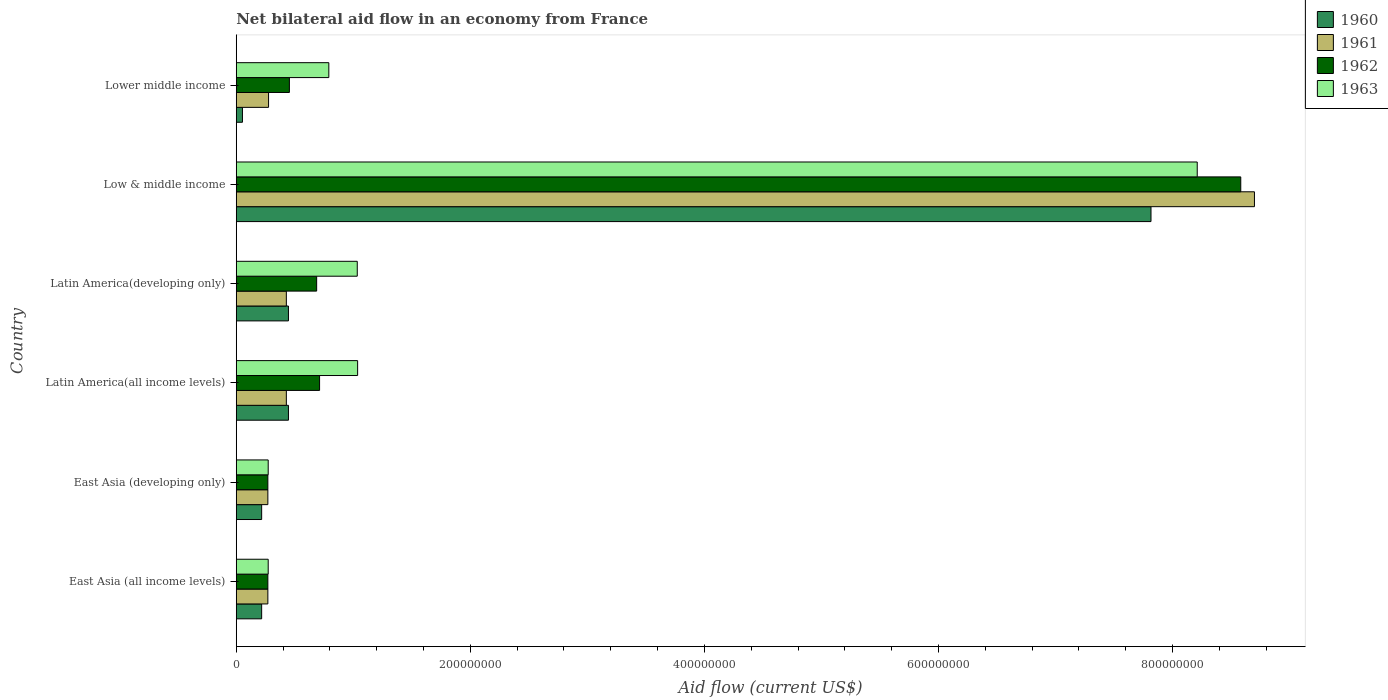Are the number of bars on each tick of the Y-axis equal?
Make the answer very short. Yes. How many bars are there on the 4th tick from the bottom?
Your answer should be compact. 4. What is the label of the 1st group of bars from the top?
Give a very brief answer. Lower middle income. What is the net bilateral aid flow in 1960 in East Asia (all income levels)?
Offer a very short reply. 2.17e+07. Across all countries, what is the maximum net bilateral aid flow in 1960?
Offer a very short reply. 7.82e+08. Across all countries, what is the minimum net bilateral aid flow in 1961?
Your answer should be compact. 2.70e+07. In which country was the net bilateral aid flow in 1962 maximum?
Offer a very short reply. Low & middle income. In which country was the net bilateral aid flow in 1963 minimum?
Your answer should be very brief. East Asia (all income levels). What is the total net bilateral aid flow in 1962 in the graph?
Provide a succinct answer. 1.10e+09. What is the difference between the net bilateral aid flow in 1961 in East Asia (developing only) and that in Latin America(developing only)?
Your answer should be very brief. -1.58e+07. What is the difference between the net bilateral aid flow in 1962 in Latin America(all income levels) and the net bilateral aid flow in 1960 in East Asia (developing only)?
Provide a short and direct response. 4.95e+07. What is the average net bilateral aid flow in 1962 per country?
Offer a terse response. 1.83e+08. What is the difference between the net bilateral aid flow in 1961 and net bilateral aid flow in 1963 in East Asia (developing only)?
Your answer should be very brief. -3.00e+05. What is the ratio of the net bilateral aid flow in 1960 in Latin America(all income levels) to that in Low & middle income?
Provide a short and direct response. 0.06. What is the difference between the highest and the second highest net bilateral aid flow in 1960?
Offer a terse response. 7.37e+08. What is the difference between the highest and the lowest net bilateral aid flow in 1960?
Your response must be concise. 7.76e+08. In how many countries, is the net bilateral aid flow in 1963 greater than the average net bilateral aid flow in 1963 taken over all countries?
Give a very brief answer. 1. Is the sum of the net bilateral aid flow in 1962 in Latin America(developing only) and Lower middle income greater than the maximum net bilateral aid flow in 1961 across all countries?
Your answer should be very brief. No. Is it the case that in every country, the sum of the net bilateral aid flow in 1961 and net bilateral aid flow in 1963 is greater than the sum of net bilateral aid flow in 1960 and net bilateral aid flow in 1962?
Make the answer very short. No. What does the 4th bar from the top in East Asia (all income levels) represents?
Provide a succinct answer. 1960. What does the 1st bar from the bottom in Latin America(developing only) represents?
Ensure brevity in your answer.  1960. How many bars are there?
Ensure brevity in your answer.  24. Are all the bars in the graph horizontal?
Your answer should be compact. Yes. What is the difference between two consecutive major ticks on the X-axis?
Keep it short and to the point. 2.00e+08. Does the graph contain any zero values?
Ensure brevity in your answer.  No. Where does the legend appear in the graph?
Provide a succinct answer. Top right. How many legend labels are there?
Your answer should be very brief. 4. What is the title of the graph?
Keep it short and to the point. Net bilateral aid flow in an economy from France. Does "2014" appear as one of the legend labels in the graph?
Offer a very short reply. No. What is the label or title of the X-axis?
Make the answer very short. Aid flow (current US$). What is the label or title of the Y-axis?
Your answer should be compact. Country. What is the Aid flow (current US$) of 1960 in East Asia (all income levels)?
Provide a short and direct response. 2.17e+07. What is the Aid flow (current US$) in 1961 in East Asia (all income levels)?
Provide a short and direct response. 2.70e+07. What is the Aid flow (current US$) in 1962 in East Asia (all income levels)?
Offer a very short reply. 2.70e+07. What is the Aid flow (current US$) in 1963 in East Asia (all income levels)?
Your answer should be very brief. 2.73e+07. What is the Aid flow (current US$) in 1960 in East Asia (developing only)?
Offer a very short reply. 2.17e+07. What is the Aid flow (current US$) of 1961 in East Asia (developing only)?
Give a very brief answer. 2.70e+07. What is the Aid flow (current US$) in 1962 in East Asia (developing only)?
Your answer should be compact. 2.70e+07. What is the Aid flow (current US$) in 1963 in East Asia (developing only)?
Give a very brief answer. 2.73e+07. What is the Aid flow (current US$) in 1960 in Latin America(all income levels)?
Give a very brief answer. 4.46e+07. What is the Aid flow (current US$) of 1961 in Latin America(all income levels)?
Offer a very short reply. 4.28e+07. What is the Aid flow (current US$) of 1962 in Latin America(all income levels)?
Provide a succinct answer. 7.12e+07. What is the Aid flow (current US$) of 1963 in Latin America(all income levels)?
Ensure brevity in your answer.  1.04e+08. What is the Aid flow (current US$) of 1960 in Latin America(developing only)?
Ensure brevity in your answer.  4.46e+07. What is the Aid flow (current US$) in 1961 in Latin America(developing only)?
Keep it short and to the point. 4.28e+07. What is the Aid flow (current US$) in 1962 in Latin America(developing only)?
Give a very brief answer. 6.87e+07. What is the Aid flow (current US$) of 1963 in Latin America(developing only)?
Make the answer very short. 1.03e+08. What is the Aid flow (current US$) of 1960 in Low & middle income?
Offer a very short reply. 7.82e+08. What is the Aid flow (current US$) in 1961 in Low & middle income?
Offer a terse response. 8.70e+08. What is the Aid flow (current US$) of 1962 in Low & middle income?
Offer a terse response. 8.58e+08. What is the Aid flow (current US$) of 1963 in Low & middle income?
Your answer should be compact. 8.21e+08. What is the Aid flow (current US$) of 1960 in Lower middle income?
Offer a terse response. 5.30e+06. What is the Aid flow (current US$) in 1961 in Lower middle income?
Give a very brief answer. 2.76e+07. What is the Aid flow (current US$) of 1962 in Lower middle income?
Provide a short and direct response. 4.54e+07. What is the Aid flow (current US$) of 1963 in Lower middle income?
Make the answer very short. 7.91e+07. Across all countries, what is the maximum Aid flow (current US$) in 1960?
Make the answer very short. 7.82e+08. Across all countries, what is the maximum Aid flow (current US$) of 1961?
Give a very brief answer. 8.70e+08. Across all countries, what is the maximum Aid flow (current US$) in 1962?
Your answer should be very brief. 8.58e+08. Across all countries, what is the maximum Aid flow (current US$) of 1963?
Offer a very short reply. 8.21e+08. Across all countries, what is the minimum Aid flow (current US$) of 1960?
Keep it short and to the point. 5.30e+06. Across all countries, what is the minimum Aid flow (current US$) of 1961?
Provide a short and direct response. 2.70e+07. Across all countries, what is the minimum Aid flow (current US$) of 1962?
Offer a very short reply. 2.70e+07. Across all countries, what is the minimum Aid flow (current US$) in 1963?
Your response must be concise. 2.73e+07. What is the total Aid flow (current US$) in 1960 in the graph?
Offer a very short reply. 9.20e+08. What is the total Aid flow (current US$) in 1961 in the graph?
Your answer should be very brief. 1.04e+09. What is the total Aid flow (current US$) of 1962 in the graph?
Give a very brief answer. 1.10e+09. What is the total Aid flow (current US$) of 1963 in the graph?
Your answer should be compact. 1.16e+09. What is the difference between the Aid flow (current US$) in 1961 in East Asia (all income levels) and that in East Asia (developing only)?
Offer a very short reply. 0. What is the difference between the Aid flow (current US$) in 1963 in East Asia (all income levels) and that in East Asia (developing only)?
Provide a short and direct response. 0. What is the difference between the Aid flow (current US$) in 1960 in East Asia (all income levels) and that in Latin America(all income levels)?
Keep it short and to the point. -2.29e+07. What is the difference between the Aid flow (current US$) in 1961 in East Asia (all income levels) and that in Latin America(all income levels)?
Offer a terse response. -1.58e+07. What is the difference between the Aid flow (current US$) of 1962 in East Asia (all income levels) and that in Latin America(all income levels)?
Make the answer very short. -4.42e+07. What is the difference between the Aid flow (current US$) in 1963 in East Asia (all income levels) and that in Latin America(all income levels)?
Provide a short and direct response. -7.64e+07. What is the difference between the Aid flow (current US$) of 1960 in East Asia (all income levels) and that in Latin America(developing only)?
Offer a terse response. -2.29e+07. What is the difference between the Aid flow (current US$) of 1961 in East Asia (all income levels) and that in Latin America(developing only)?
Provide a short and direct response. -1.58e+07. What is the difference between the Aid flow (current US$) of 1962 in East Asia (all income levels) and that in Latin America(developing only)?
Offer a very short reply. -4.17e+07. What is the difference between the Aid flow (current US$) of 1963 in East Asia (all income levels) and that in Latin America(developing only)?
Your answer should be compact. -7.61e+07. What is the difference between the Aid flow (current US$) in 1960 in East Asia (all income levels) and that in Low & middle income?
Offer a terse response. -7.60e+08. What is the difference between the Aid flow (current US$) of 1961 in East Asia (all income levels) and that in Low & middle income?
Provide a short and direct response. -8.43e+08. What is the difference between the Aid flow (current US$) in 1962 in East Asia (all income levels) and that in Low & middle income?
Provide a short and direct response. -8.31e+08. What is the difference between the Aid flow (current US$) in 1963 in East Asia (all income levels) and that in Low & middle income?
Your answer should be compact. -7.94e+08. What is the difference between the Aid flow (current US$) in 1960 in East Asia (all income levels) and that in Lower middle income?
Your answer should be compact. 1.64e+07. What is the difference between the Aid flow (current US$) in 1961 in East Asia (all income levels) and that in Lower middle income?
Your response must be concise. -6.00e+05. What is the difference between the Aid flow (current US$) of 1962 in East Asia (all income levels) and that in Lower middle income?
Ensure brevity in your answer.  -1.84e+07. What is the difference between the Aid flow (current US$) in 1963 in East Asia (all income levels) and that in Lower middle income?
Provide a short and direct response. -5.18e+07. What is the difference between the Aid flow (current US$) of 1960 in East Asia (developing only) and that in Latin America(all income levels)?
Offer a terse response. -2.29e+07. What is the difference between the Aid flow (current US$) of 1961 in East Asia (developing only) and that in Latin America(all income levels)?
Provide a short and direct response. -1.58e+07. What is the difference between the Aid flow (current US$) of 1962 in East Asia (developing only) and that in Latin America(all income levels)?
Provide a succinct answer. -4.42e+07. What is the difference between the Aid flow (current US$) of 1963 in East Asia (developing only) and that in Latin America(all income levels)?
Provide a short and direct response. -7.64e+07. What is the difference between the Aid flow (current US$) of 1960 in East Asia (developing only) and that in Latin America(developing only)?
Your answer should be compact. -2.29e+07. What is the difference between the Aid flow (current US$) of 1961 in East Asia (developing only) and that in Latin America(developing only)?
Offer a very short reply. -1.58e+07. What is the difference between the Aid flow (current US$) in 1962 in East Asia (developing only) and that in Latin America(developing only)?
Your response must be concise. -4.17e+07. What is the difference between the Aid flow (current US$) of 1963 in East Asia (developing only) and that in Latin America(developing only)?
Your response must be concise. -7.61e+07. What is the difference between the Aid flow (current US$) of 1960 in East Asia (developing only) and that in Low & middle income?
Ensure brevity in your answer.  -7.60e+08. What is the difference between the Aid flow (current US$) in 1961 in East Asia (developing only) and that in Low & middle income?
Offer a terse response. -8.43e+08. What is the difference between the Aid flow (current US$) in 1962 in East Asia (developing only) and that in Low & middle income?
Give a very brief answer. -8.31e+08. What is the difference between the Aid flow (current US$) in 1963 in East Asia (developing only) and that in Low & middle income?
Your answer should be compact. -7.94e+08. What is the difference between the Aid flow (current US$) of 1960 in East Asia (developing only) and that in Lower middle income?
Ensure brevity in your answer.  1.64e+07. What is the difference between the Aid flow (current US$) of 1961 in East Asia (developing only) and that in Lower middle income?
Your answer should be very brief. -6.00e+05. What is the difference between the Aid flow (current US$) in 1962 in East Asia (developing only) and that in Lower middle income?
Make the answer very short. -1.84e+07. What is the difference between the Aid flow (current US$) in 1963 in East Asia (developing only) and that in Lower middle income?
Your answer should be very brief. -5.18e+07. What is the difference between the Aid flow (current US$) of 1960 in Latin America(all income levels) and that in Latin America(developing only)?
Keep it short and to the point. 0. What is the difference between the Aid flow (current US$) of 1962 in Latin America(all income levels) and that in Latin America(developing only)?
Keep it short and to the point. 2.50e+06. What is the difference between the Aid flow (current US$) of 1963 in Latin America(all income levels) and that in Latin America(developing only)?
Offer a terse response. 3.00e+05. What is the difference between the Aid flow (current US$) of 1960 in Latin America(all income levels) and that in Low & middle income?
Give a very brief answer. -7.37e+08. What is the difference between the Aid flow (current US$) of 1961 in Latin America(all income levels) and that in Low & middle income?
Ensure brevity in your answer.  -8.27e+08. What is the difference between the Aid flow (current US$) in 1962 in Latin America(all income levels) and that in Low & middle income?
Your response must be concise. -7.87e+08. What is the difference between the Aid flow (current US$) in 1963 in Latin America(all income levels) and that in Low & middle income?
Your answer should be very brief. -7.17e+08. What is the difference between the Aid flow (current US$) in 1960 in Latin America(all income levels) and that in Lower middle income?
Provide a succinct answer. 3.93e+07. What is the difference between the Aid flow (current US$) of 1961 in Latin America(all income levels) and that in Lower middle income?
Provide a succinct answer. 1.52e+07. What is the difference between the Aid flow (current US$) of 1962 in Latin America(all income levels) and that in Lower middle income?
Your answer should be compact. 2.58e+07. What is the difference between the Aid flow (current US$) of 1963 in Latin America(all income levels) and that in Lower middle income?
Offer a very short reply. 2.46e+07. What is the difference between the Aid flow (current US$) of 1960 in Latin America(developing only) and that in Low & middle income?
Provide a short and direct response. -7.37e+08. What is the difference between the Aid flow (current US$) in 1961 in Latin America(developing only) and that in Low & middle income?
Make the answer very short. -8.27e+08. What is the difference between the Aid flow (current US$) in 1962 in Latin America(developing only) and that in Low & middle income?
Make the answer very short. -7.90e+08. What is the difference between the Aid flow (current US$) in 1963 in Latin America(developing only) and that in Low & middle income?
Provide a succinct answer. -7.18e+08. What is the difference between the Aid flow (current US$) in 1960 in Latin America(developing only) and that in Lower middle income?
Provide a short and direct response. 3.93e+07. What is the difference between the Aid flow (current US$) in 1961 in Latin America(developing only) and that in Lower middle income?
Your response must be concise. 1.52e+07. What is the difference between the Aid flow (current US$) in 1962 in Latin America(developing only) and that in Lower middle income?
Keep it short and to the point. 2.33e+07. What is the difference between the Aid flow (current US$) of 1963 in Latin America(developing only) and that in Lower middle income?
Ensure brevity in your answer.  2.43e+07. What is the difference between the Aid flow (current US$) in 1960 in Low & middle income and that in Lower middle income?
Offer a terse response. 7.76e+08. What is the difference between the Aid flow (current US$) of 1961 in Low & middle income and that in Lower middle income?
Make the answer very short. 8.42e+08. What is the difference between the Aid flow (current US$) in 1962 in Low & middle income and that in Lower middle income?
Your answer should be compact. 8.13e+08. What is the difference between the Aid flow (current US$) in 1963 in Low & middle income and that in Lower middle income?
Your response must be concise. 7.42e+08. What is the difference between the Aid flow (current US$) of 1960 in East Asia (all income levels) and the Aid flow (current US$) of 1961 in East Asia (developing only)?
Provide a short and direct response. -5.30e+06. What is the difference between the Aid flow (current US$) in 1960 in East Asia (all income levels) and the Aid flow (current US$) in 1962 in East Asia (developing only)?
Ensure brevity in your answer.  -5.30e+06. What is the difference between the Aid flow (current US$) of 1960 in East Asia (all income levels) and the Aid flow (current US$) of 1963 in East Asia (developing only)?
Your answer should be compact. -5.60e+06. What is the difference between the Aid flow (current US$) of 1961 in East Asia (all income levels) and the Aid flow (current US$) of 1962 in East Asia (developing only)?
Ensure brevity in your answer.  0. What is the difference between the Aid flow (current US$) of 1961 in East Asia (all income levels) and the Aid flow (current US$) of 1963 in East Asia (developing only)?
Offer a terse response. -3.00e+05. What is the difference between the Aid flow (current US$) in 1960 in East Asia (all income levels) and the Aid flow (current US$) in 1961 in Latin America(all income levels)?
Provide a short and direct response. -2.11e+07. What is the difference between the Aid flow (current US$) in 1960 in East Asia (all income levels) and the Aid flow (current US$) in 1962 in Latin America(all income levels)?
Provide a short and direct response. -4.95e+07. What is the difference between the Aid flow (current US$) in 1960 in East Asia (all income levels) and the Aid flow (current US$) in 1963 in Latin America(all income levels)?
Keep it short and to the point. -8.20e+07. What is the difference between the Aid flow (current US$) in 1961 in East Asia (all income levels) and the Aid flow (current US$) in 1962 in Latin America(all income levels)?
Your answer should be very brief. -4.42e+07. What is the difference between the Aid flow (current US$) of 1961 in East Asia (all income levels) and the Aid flow (current US$) of 1963 in Latin America(all income levels)?
Your answer should be compact. -7.67e+07. What is the difference between the Aid flow (current US$) of 1962 in East Asia (all income levels) and the Aid flow (current US$) of 1963 in Latin America(all income levels)?
Provide a succinct answer. -7.67e+07. What is the difference between the Aid flow (current US$) of 1960 in East Asia (all income levels) and the Aid flow (current US$) of 1961 in Latin America(developing only)?
Your response must be concise. -2.11e+07. What is the difference between the Aid flow (current US$) in 1960 in East Asia (all income levels) and the Aid flow (current US$) in 1962 in Latin America(developing only)?
Provide a succinct answer. -4.70e+07. What is the difference between the Aid flow (current US$) in 1960 in East Asia (all income levels) and the Aid flow (current US$) in 1963 in Latin America(developing only)?
Your answer should be compact. -8.17e+07. What is the difference between the Aid flow (current US$) of 1961 in East Asia (all income levels) and the Aid flow (current US$) of 1962 in Latin America(developing only)?
Offer a very short reply. -4.17e+07. What is the difference between the Aid flow (current US$) in 1961 in East Asia (all income levels) and the Aid flow (current US$) in 1963 in Latin America(developing only)?
Provide a succinct answer. -7.64e+07. What is the difference between the Aid flow (current US$) of 1962 in East Asia (all income levels) and the Aid flow (current US$) of 1963 in Latin America(developing only)?
Offer a very short reply. -7.64e+07. What is the difference between the Aid flow (current US$) of 1960 in East Asia (all income levels) and the Aid flow (current US$) of 1961 in Low & middle income?
Make the answer very short. -8.48e+08. What is the difference between the Aid flow (current US$) of 1960 in East Asia (all income levels) and the Aid flow (current US$) of 1962 in Low & middle income?
Offer a terse response. -8.37e+08. What is the difference between the Aid flow (current US$) in 1960 in East Asia (all income levels) and the Aid flow (current US$) in 1963 in Low & middle income?
Keep it short and to the point. -7.99e+08. What is the difference between the Aid flow (current US$) in 1961 in East Asia (all income levels) and the Aid flow (current US$) in 1962 in Low & middle income?
Provide a short and direct response. -8.31e+08. What is the difference between the Aid flow (current US$) of 1961 in East Asia (all income levels) and the Aid flow (current US$) of 1963 in Low & middle income?
Provide a short and direct response. -7.94e+08. What is the difference between the Aid flow (current US$) of 1962 in East Asia (all income levels) and the Aid flow (current US$) of 1963 in Low & middle income?
Your answer should be compact. -7.94e+08. What is the difference between the Aid flow (current US$) in 1960 in East Asia (all income levels) and the Aid flow (current US$) in 1961 in Lower middle income?
Make the answer very short. -5.90e+06. What is the difference between the Aid flow (current US$) in 1960 in East Asia (all income levels) and the Aid flow (current US$) in 1962 in Lower middle income?
Your answer should be very brief. -2.37e+07. What is the difference between the Aid flow (current US$) in 1960 in East Asia (all income levels) and the Aid flow (current US$) in 1963 in Lower middle income?
Give a very brief answer. -5.74e+07. What is the difference between the Aid flow (current US$) of 1961 in East Asia (all income levels) and the Aid flow (current US$) of 1962 in Lower middle income?
Your response must be concise. -1.84e+07. What is the difference between the Aid flow (current US$) in 1961 in East Asia (all income levels) and the Aid flow (current US$) in 1963 in Lower middle income?
Keep it short and to the point. -5.21e+07. What is the difference between the Aid flow (current US$) of 1962 in East Asia (all income levels) and the Aid flow (current US$) of 1963 in Lower middle income?
Keep it short and to the point. -5.21e+07. What is the difference between the Aid flow (current US$) of 1960 in East Asia (developing only) and the Aid flow (current US$) of 1961 in Latin America(all income levels)?
Provide a succinct answer. -2.11e+07. What is the difference between the Aid flow (current US$) in 1960 in East Asia (developing only) and the Aid flow (current US$) in 1962 in Latin America(all income levels)?
Offer a very short reply. -4.95e+07. What is the difference between the Aid flow (current US$) of 1960 in East Asia (developing only) and the Aid flow (current US$) of 1963 in Latin America(all income levels)?
Provide a short and direct response. -8.20e+07. What is the difference between the Aid flow (current US$) of 1961 in East Asia (developing only) and the Aid flow (current US$) of 1962 in Latin America(all income levels)?
Provide a succinct answer. -4.42e+07. What is the difference between the Aid flow (current US$) in 1961 in East Asia (developing only) and the Aid flow (current US$) in 1963 in Latin America(all income levels)?
Your answer should be very brief. -7.67e+07. What is the difference between the Aid flow (current US$) of 1962 in East Asia (developing only) and the Aid flow (current US$) of 1963 in Latin America(all income levels)?
Your answer should be very brief. -7.67e+07. What is the difference between the Aid flow (current US$) of 1960 in East Asia (developing only) and the Aid flow (current US$) of 1961 in Latin America(developing only)?
Offer a very short reply. -2.11e+07. What is the difference between the Aid flow (current US$) in 1960 in East Asia (developing only) and the Aid flow (current US$) in 1962 in Latin America(developing only)?
Offer a very short reply. -4.70e+07. What is the difference between the Aid flow (current US$) in 1960 in East Asia (developing only) and the Aid flow (current US$) in 1963 in Latin America(developing only)?
Your answer should be compact. -8.17e+07. What is the difference between the Aid flow (current US$) of 1961 in East Asia (developing only) and the Aid flow (current US$) of 1962 in Latin America(developing only)?
Your answer should be compact. -4.17e+07. What is the difference between the Aid flow (current US$) in 1961 in East Asia (developing only) and the Aid flow (current US$) in 1963 in Latin America(developing only)?
Provide a short and direct response. -7.64e+07. What is the difference between the Aid flow (current US$) of 1962 in East Asia (developing only) and the Aid flow (current US$) of 1963 in Latin America(developing only)?
Make the answer very short. -7.64e+07. What is the difference between the Aid flow (current US$) in 1960 in East Asia (developing only) and the Aid flow (current US$) in 1961 in Low & middle income?
Ensure brevity in your answer.  -8.48e+08. What is the difference between the Aid flow (current US$) in 1960 in East Asia (developing only) and the Aid flow (current US$) in 1962 in Low & middle income?
Offer a terse response. -8.37e+08. What is the difference between the Aid flow (current US$) of 1960 in East Asia (developing only) and the Aid flow (current US$) of 1963 in Low & middle income?
Your response must be concise. -7.99e+08. What is the difference between the Aid flow (current US$) of 1961 in East Asia (developing only) and the Aid flow (current US$) of 1962 in Low & middle income?
Offer a terse response. -8.31e+08. What is the difference between the Aid flow (current US$) in 1961 in East Asia (developing only) and the Aid flow (current US$) in 1963 in Low & middle income?
Ensure brevity in your answer.  -7.94e+08. What is the difference between the Aid flow (current US$) in 1962 in East Asia (developing only) and the Aid flow (current US$) in 1963 in Low & middle income?
Make the answer very short. -7.94e+08. What is the difference between the Aid flow (current US$) in 1960 in East Asia (developing only) and the Aid flow (current US$) in 1961 in Lower middle income?
Your answer should be compact. -5.90e+06. What is the difference between the Aid flow (current US$) of 1960 in East Asia (developing only) and the Aid flow (current US$) of 1962 in Lower middle income?
Ensure brevity in your answer.  -2.37e+07. What is the difference between the Aid flow (current US$) of 1960 in East Asia (developing only) and the Aid flow (current US$) of 1963 in Lower middle income?
Offer a terse response. -5.74e+07. What is the difference between the Aid flow (current US$) of 1961 in East Asia (developing only) and the Aid flow (current US$) of 1962 in Lower middle income?
Your response must be concise. -1.84e+07. What is the difference between the Aid flow (current US$) in 1961 in East Asia (developing only) and the Aid flow (current US$) in 1963 in Lower middle income?
Your answer should be very brief. -5.21e+07. What is the difference between the Aid flow (current US$) of 1962 in East Asia (developing only) and the Aid flow (current US$) of 1963 in Lower middle income?
Give a very brief answer. -5.21e+07. What is the difference between the Aid flow (current US$) in 1960 in Latin America(all income levels) and the Aid flow (current US$) in 1961 in Latin America(developing only)?
Offer a very short reply. 1.80e+06. What is the difference between the Aid flow (current US$) of 1960 in Latin America(all income levels) and the Aid flow (current US$) of 1962 in Latin America(developing only)?
Provide a short and direct response. -2.41e+07. What is the difference between the Aid flow (current US$) in 1960 in Latin America(all income levels) and the Aid flow (current US$) in 1963 in Latin America(developing only)?
Your answer should be very brief. -5.88e+07. What is the difference between the Aid flow (current US$) in 1961 in Latin America(all income levels) and the Aid flow (current US$) in 1962 in Latin America(developing only)?
Your response must be concise. -2.59e+07. What is the difference between the Aid flow (current US$) of 1961 in Latin America(all income levels) and the Aid flow (current US$) of 1963 in Latin America(developing only)?
Provide a short and direct response. -6.06e+07. What is the difference between the Aid flow (current US$) in 1962 in Latin America(all income levels) and the Aid flow (current US$) in 1963 in Latin America(developing only)?
Offer a very short reply. -3.22e+07. What is the difference between the Aid flow (current US$) of 1960 in Latin America(all income levels) and the Aid flow (current US$) of 1961 in Low & middle income?
Offer a terse response. -8.25e+08. What is the difference between the Aid flow (current US$) of 1960 in Latin America(all income levels) and the Aid flow (current US$) of 1962 in Low & middle income?
Make the answer very short. -8.14e+08. What is the difference between the Aid flow (current US$) of 1960 in Latin America(all income levels) and the Aid flow (current US$) of 1963 in Low & middle income?
Provide a succinct answer. -7.76e+08. What is the difference between the Aid flow (current US$) of 1961 in Latin America(all income levels) and the Aid flow (current US$) of 1962 in Low & middle income?
Provide a short and direct response. -8.16e+08. What is the difference between the Aid flow (current US$) of 1961 in Latin America(all income levels) and the Aid flow (current US$) of 1963 in Low & middle income?
Give a very brief answer. -7.78e+08. What is the difference between the Aid flow (current US$) in 1962 in Latin America(all income levels) and the Aid flow (current US$) in 1963 in Low & middle income?
Make the answer very short. -7.50e+08. What is the difference between the Aid flow (current US$) in 1960 in Latin America(all income levels) and the Aid flow (current US$) in 1961 in Lower middle income?
Provide a short and direct response. 1.70e+07. What is the difference between the Aid flow (current US$) of 1960 in Latin America(all income levels) and the Aid flow (current US$) of 1962 in Lower middle income?
Your response must be concise. -8.00e+05. What is the difference between the Aid flow (current US$) of 1960 in Latin America(all income levels) and the Aid flow (current US$) of 1963 in Lower middle income?
Make the answer very short. -3.45e+07. What is the difference between the Aid flow (current US$) in 1961 in Latin America(all income levels) and the Aid flow (current US$) in 1962 in Lower middle income?
Make the answer very short. -2.60e+06. What is the difference between the Aid flow (current US$) in 1961 in Latin America(all income levels) and the Aid flow (current US$) in 1963 in Lower middle income?
Provide a short and direct response. -3.63e+07. What is the difference between the Aid flow (current US$) in 1962 in Latin America(all income levels) and the Aid flow (current US$) in 1963 in Lower middle income?
Make the answer very short. -7.90e+06. What is the difference between the Aid flow (current US$) in 1960 in Latin America(developing only) and the Aid flow (current US$) in 1961 in Low & middle income?
Offer a terse response. -8.25e+08. What is the difference between the Aid flow (current US$) in 1960 in Latin America(developing only) and the Aid flow (current US$) in 1962 in Low & middle income?
Your response must be concise. -8.14e+08. What is the difference between the Aid flow (current US$) in 1960 in Latin America(developing only) and the Aid flow (current US$) in 1963 in Low & middle income?
Provide a short and direct response. -7.76e+08. What is the difference between the Aid flow (current US$) of 1961 in Latin America(developing only) and the Aid flow (current US$) of 1962 in Low & middle income?
Provide a short and direct response. -8.16e+08. What is the difference between the Aid flow (current US$) in 1961 in Latin America(developing only) and the Aid flow (current US$) in 1963 in Low & middle income?
Provide a short and direct response. -7.78e+08. What is the difference between the Aid flow (current US$) in 1962 in Latin America(developing only) and the Aid flow (current US$) in 1963 in Low & middle income?
Give a very brief answer. -7.52e+08. What is the difference between the Aid flow (current US$) of 1960 in Latin America(developing only) and the Aid flow (current US$) of 1961 in Lower middle income?
Provide a short and direct response. 1.70e+07. What is the difference between the Aid flow (current US$) in 1960 in Latin America(developing only) and the Aid flow (current US$) in 1962 in Lower middle income?
Give a very brief answer. -8.00e+05. What is the difference between the Aid flow (current US$) of 1960 in Latin America(developing only) and the Aid flow (current US$) of 1963 in Lower middle income?
Ensure brevity in your answer.  -3.45e+07. What is the difference between the Aid flow (current US$) of 1961 in Latin America(developing only) and the Aid flow (current US$) of 1962 in Lower middle income?
Your answer should be very brief. -2.60e+06. What is the difference between the Aid flow (current US$) in 1961 in Latin America(developing only) and the Aid flow (current US$) in 1963 in Lower middle income?
Offer a very short reply. -3.63e+07. What is the difference between the Aid flow (current US$) in 1962 in Latin America(developing only) and the Aid flow (current US$) in 1963 in Lower middle income?
Provide a succinct answer. -1.04e+07. What is the difference between the Aid flow (current US$) of 1960 in Low & middle income and the Aid flow (current US$) of 1961 in Lower middle income?
Make the answer very short. 7.54e+08. What is the difference between the Aid flow (current US$) in 1960 in Low & middle income and the Aid flow (current US$) in 1962 in Lower middle income?
Your response must be concise. 7.36e+08. What is the difference between the Aid flow (current US$) of 1960 in Low & middle income and the Aid flow (current US$) of 1963 in Lower middle income?
Keep it short and to the point. 7.02e+08. What is the difference between the Aid flow (current US$) in 1961 in Low & middle income and the Aid flow (current US$) in 1962 in Lower middle income?
Offer a very short reply. 8.25e+08. What is the difference between the Aid flow (current US$) in 1961 in Low & middle income and the Aid flow (current US$) in 1963 in Lower middle income?
Give a very brief answer. 7.91e+08. What is the difference between the Aid flow (current US$) of 1962 in Low & middle income and the Aid flow (current US$) of 1963 in Lower middle income?
Your answer should be very brief. 7.79e+08. What is the average Aid flow (current US$) in 1960 per country?
Make the answer very short. 1.53e+08. What is the average Aid flow (current US$) of 1961 per country?
Your response must be concise. 1.73e+08. What is the average Aid flow (current US$) in 1962 per country?
Provide a short and direct response. 1.83e+08. What is the average Aid flow (current US$) of 1963 per country?
Offer a terse response. 1.94e+08. What is the difference between the Aid flow (current US$) in 1960 and Aid flow (current US$) in 1961 in East Asia (all income levels)?
Provide a succinct answer. -5.30e+06. What is the difference between the Aid flow (current US$) in 1960 and Aid flow (current US$) in 1962 in East Asia (all income levels)?
Your answer should be very brief. -5.30e+06. What is the difference between the Aid flow (current US$) in 1960 and Aid flow (current US$) in 1963 in East Asia (all income levels)?
Your response must be concise. -5.60e+06. What is the difference between the Aid flow (current US$) in 1961 and Aid flow (current US$) in 1963 in East Asia (all income levels)?
Offer a very short reply. -3.00e+05. What is the difference between the Aid flow (current US$) in 1962 and Aid flow (current US$) in 1963 in East Asia (all income levels)?
Provide a short and direct response. -3.00e+05. What is the difference between the Aid flow (current US$) in 1960 and Aid flow (current US$) in 1961 in East Asia (developing only)?
Offer a terse response. -5.30e+06. What is the difference between the Aid flow (current US$) of 1960 and Aid flow (current US$) of 1962 in East Asia (developing only)?
Provide a succinct answer. -5.30e+06. What is the difference between the Aid flow (current US$) in 1960 and Aid flow (current US$) in 1963 in East Asia (developing only)?
Offer a very short reply. -5.60e+06. What is the difference between the Aid flow (current US$) of 1961 and Aid flow (current US$) of 1962 in East Asia (developing only)?
Keep it short and to the point. 0. What is the difference between the Aid flow (current US$) of 1961 and Aid flow (current US$) of 1963 in East Asia (developing only)?
Provide a succinct answer. -3.00e+05. What is the difference between the Aid flow (current US$) in 1962 and Aid flow (current US$) in 1963 in East Asia (developing only)?
Make the answer very short. -3.00e+05. What is the difference between the Aid flow (current US$) of 1960 and Aid flow (current US$) of 1961 in Latin America(all income levels)?
Your response must be concise. 1.80e+06. What is the difference between the Aid flow (current US$) of 1960 and Aid flow (current US$) of 1962 in Latin America(all income levels)?
Give a very brief answer. -2.66e+07. What is the difference between the Aid flow (current US$) in 1960 and Aid flow (current US$) in 1963 in Latin America(all income levels)?
Give a very brief answer. -5.91e+07. What is the difference between the Aid flow (current US$) in 1961 and Aid flow (current US$) in 1962 in Latin America(all income levels)?
Keep it short and to the point. -2.84e+07. What is the difference between the Aid flow (current US$) of 1961 and Aid flow (current US$) of 1963 in Latin America(all income levels)?
Offer a very short reply. -6.09e+07. What is the difference between the Aid flow (current US$) of 1962 and Aid flow (current US$) of 1963 in Latin America(all income levels)?
Your answer should be compact. -3.25e+07. What is the difference between the Aid flow (current US$) of 1960 and Aid flow (current US$) of 1961 in Latin America(developing only)?
Ensure brevity in your answer.  1.80e+06. What is the difference between the Aid flow (current US$) in 1960 and Aid flow (current US$) in 1962 in Latin America(developing only)?
Your answer should be very brief. -2.41e+07. What is the difference between the Aid flow (current US$) of 1960 and Aid flow (current US$) of 1963 in Latin America(developing only)?
Your answer should be compact. -5.88e+07. What is the difference between the Aid flow (current US$) in 1961 and Aid flow (current US$) in 1962 in Latin America(developing only)?
Offer a terse response. -2.59e+07. What is the difference between the Aid flow (current US$) in 1961 and Aid flow (current US$) in 1963 in Latin America(developing only)?
Give a very brief answer. -6.06e+07. What is the difference between the Aid flow (current US$) in 1962 and Aid flow (current US$) in 1963 in Latin America(developing only)?
Your answer should be compact. -3.47e+07. What is the difference between the Aid flow (current US$) of 1960 and Aid flow (current US$) of 1961 in Low & middle income?
Give a very brief answer. -8.84e+07. What is the difference between the Aid flow (current US$) in 1960 and Aid flow (current US$) in 1962 in Low & middle income?
Give a very brief answer. -7.67e+07. What is the difference between the Aid flow (current US$) in 1960 and Aid flow (current US$) in 1963 in Low & middle income?
Provide a succinct answer. -3.95e+07. What is the difference between the Aid flow (current US$) in 1961 and Aid flow (current US$) in 1962 in Low & middle income?
Your response must be concise. 1.17e+07. What is the difference between the Aid flow (current US$) of 1961 and Aid flow (current US$) of 1963 in Low & middle income?
Provide a succinct answer. 4.89e+07. What is the difference between the Aid flow (current US$) of 1962 and Aid flow (current US$) of 1963 in Low & middle income?
Your response must be concise. 3.72e+07. What is the difference between the Aid flow (current US$) of 1960 and Aid flow (current US$) of 1961 in Lower middle income?
Your response must be concise. -2.23e+07. What is the difference between the Aid flow (current US$) in 1960 and Aid flow (current US$) in 1962 in Lower middle income?
Keep it short and to the point. -4.01e+07. What is the difference between the Aid flow (current US$) of 1960 and Aid flow (current US$) of 1963 in Lower middle income?
Your answer should be very brief. -7.38e+07. What is the difference between the Aid flow (current US$) in 1961 and Aid flow (current US$) in 1962 in Lower middle income?
Offer a terse response. -1.78e+07. What is the difference between the Aid flow (current US$) in 1961 and Aid flow (current US$) in 1963 in Lower middle income?
Make the answer very short. -5.15e+07. What is the difference between the Aid flow (current US$) in 1962 and Aid flow (current US$) in 1963 in Lower middle income?
Give a very brief answer. -3.37e+07. What is the ratio of the Aid flow (current US$) in 1960 in East Asia (all income levels) to that in East Asia (developing only)?
Your response must be concise. 1. What is the ratio of the Aid flow (current US$) of 1961 in East Asia (all income levels) to that in East Asia (developing only)?
Your response must be concise. 1. What is the ratio of the Aid flow (current US$) of 1963 in East Asia (all income levels) to that in East Asia (developing only)?
Your answer should be very brief. 1. What is the ratio of the Aid flow (current US$) in 1960 in East Asia (all income levels) to that in Latin America(all income levels)?
Ensure brevity in your answer.  0.49. What is the ratio of the Aid flow (current US$) of 1961 in East Asia (all income levels) to that in Latin America(all income levels)?
Keep it short and to the point. 0.63. What is the ratio of the Aid flow (current US$) in 1962 in East Asia (all income levels) to that in Latin America(all income levels)?
Provide a short and direct response. 0.38. What is the ratio of the Aid flow (current US$) of 1963 in East Asia (all income levels) to that in Latin America(all income levels)?
Make the answer very short. 0.26. What is the ratio of the Aid flow (current US$) in 1960 in East Asia (all income levels) to that in Latin America(developing only)?
Your answer should be very brief. 0.49. What is the ratio of the Aid flow (current US$) of 1961 in East Asia (all income levels) to that in Latin America(developing only)?
Provide a succinct answer. 0.63. What is the ratio of the Aid flow (current US$) in 1962 in East Asia (all income levels) to that in Latin America(developing only)?
Offer a very short reply. 0.39. What is the ratio of the Aid flow (current US$) of 1963 in East Asia (all income levels) to that in Latin America(developing only)?
Give a very brief answer. 0.26. What is the ratio of the Aid flow (current US$) in 1960 in East Asia (all income levels) to that in Low & middle income?
Offer a terse response. 0.03. What is the ratio of the Aid flow (current US$) of 1961 in East Asia (all income levels) to that in Low & middle income?
Keep it short and to the point. 0.03. What is the ratio of the Aid flow (current US$) of 1962 in East Asia (all income levels) to that in Low & middle income?
Provide a short and direct response. 0.03. What is the ratio of the Aid flow (current US$) in 1963 in East Asia (all income levels) to that in Low & middle income?
Your answer should be very brief. 0.03. What is the ratio of the Aid flow (current US$) of 1960 in East Asia (all income levels) to that in Lower middle income?
Your answer should be very brief. 4.09. What is the ratio of the Aid flow (current US$) of 1961 in East Asia (all income levels) to that in Lower middle income?
Offer a very short reply. 0.98. What is the ratio of the Aid flow (current US$) of 1962 in East Asia (all income levels) to that in Lower middle income?
Provide a succinct answer. 0.59. What is the ratio of the Aid flow (current US$) in 1963 in East Asia (all income levels) to that in Lower middle income?
Your answer should be very brief. 0.35. What is the ratio of the Aid flow (current US$) of 1960 in East Asia (developing only) to that in Latin America(all income levels)?
Your response must be concise. 0.49. What is the ratio of the Aid flow (current US$) of 1961 in East Asia (developing only) to that in Latin America(all income levels)?
Your answer should be compact. 0.63. What is the ratio of the Aid flow (current US$) of 1962 in East Asia (developing only) to that in Latin America(all income levels)?
Your response must be concise. 0.38. What is the ratio of the Aid flow (current US$) in 1963 in East Asia (developing only) to that in Latin America(all income levels)?
Offer a terse response. 0.26. What is the ratio of the Aid flow (current US$) of 1960 in East Asia (developing only) to that in Latin America(developing only)?
Ensure brevity in your answer.  0.49. What is the ratio of the Aid flow (current US$) in 1961 in East Asia (developing only) to that in Latin America(developing only)?
Give a very brief answer. 0.63. What is the ratio of the Aid flow (current US$) in 1962 in East Asia (developing only) to that in Latin America(developing only)?
Provide a succinct answer. 0.39. What is the ratio of the Aid flow (current US$) of 1963 in East Asia (developing only) to that in Latin America(developing only)?
Your answer should be very brief. 0.26. What is the ratio of the Aid flow (current US$) of 1960 in East Asia (developing only) to that in Low & middle income?
Provide a succinct answer. 0.03. What is the ratio of the Aid flow (current US$) of 1961 in East Asia (developing only) to that in Low & middle income?
Keep it short and to the point. 0.03. What is the ratio of the Aid flow (current US$) of 1962 in East Asia (developing only) to that in Low & middle income?
Give a very brief answer. 0.03. What is the ratio of the Aid flow (current US$) of 1963 in East Asia (developing only) to that in Low & middle income?
Give a very brief answer. 0.03. What is the ratio of the Aid flow (current US$) in 1960 in East Asia (developing only) to that in Lower middle income?
Make the answer very short. 4.09. What is the ratio of the Aid flow (current US$) in 1961 in East Asia (developing only) to that in Lower middle income?
Offer a terse response. 0.98. What is the ratio of the Aid flow (current US$) in 1962 in East Asia (developing only) to that in Lower middle income?
Make the answer very short. 0.59. What is the ratio of the Aid flow (current US$) of 1963 in East Asia (developing only) to that in Lower middle income?
Offer a terse response. 0.35. What is the ratio of the Aid flow (current US$) in 1961 in Latin America(all income levels) to that in Latin America(developing only)?
Provide a short and direct response. 1. What is the ratio of the Aid flow (current US$) in 1962 in Latin America(all income levels) to that in Latin America(developing only)?
Ensure brevity in your answer.  1.04. What is the ratio of the Aid flow (current US$) of 1963 in Latin America(all income levels) to that in Latin America(developing only)?
Keep it short and to the point. 1. What is the ratio of the Aid flow (current US$) of 1960 in Latin America(all income levels) to that in Low & middle income?
Your answer should be compact. 0.06. What is the ratio of the Aid flow (current US$) in 1961 in Latin America(all income levels) to that in Low & middle income?
Make the answer very short. 0.05. What is the ratio of the Aid flow (current US$) of 1962 in Latin America(all income levels) to that in Low & middle income?
Your answer should be very brief. 0.08. What is the ratio of the Aid flow (current US$) in 1963 in Latin America(all income levels) to that in Low & middle income?
Give a very brief answer. 0.13. What is the ratio of the Aid flow (current US$) of 1960 in Latin America(all income levels) to that in Lower middle income?
Keep it short and to the point. 8.42. What is the ratio of the Aid flow (current US$) of 1961 in Latin America(all income levels) to that in Lower middle income?
Offer a terse response. 1.55. What is the ratio of the Aid flow (current US$) in 1962 in Latin America(all income levels) to that in Lower middle income?
Give a very brief answer. 1.57. What is the ratio of the Aid flow (current US$) in 1963 in Latin America(all income levels) to that in Lower middle income?
Offer a very short reply. 1.31. What is the ratio of the Aid flow (current US$) of 1960 in Latin America(developing only) to that in Low & middle income?
Keep it short and to the point. 0.06. What is the ratio of the Aid flow (current US$) of 1961 in Latin America(developing only) to that in Low & middle income?
Offer a very short reply. 0.05. What is the ratio of the Aid flow (current US$) in 1963 in Latin America(developing only) to that in Low & middle income?
Your response must be concise. 0.13. What is the ratio of the Aid flow (current US$) of 1960 in Latin America(developing only) to that in Lower middle income?
Offer a terse response. 8.42. What is the ratio of the Aid flow (current US$) of 1961 in Latin America(developing only) to that in Lower middle income?
Make the answer very short. 1.55. What is the ratio of the Aid flow (current US$) in 1962 in Latin America(developing only) to that in Lower middle income?
Keep it short and to the point. 1.51. What is the ratio of the Aid flow (current US$) of 1963 in Latin America(developing only) to that in Lower middle income?
Ensure brevity in your answer.  1.31. What is the ratio of the Aid flow (current US$) of 1960 in Low & middle income to that in Lower middle income?
Keep it short and to the point. 147.47. What is the ratio of the Aid flow (current US$) in 1961 in Low & middle income to that in Lower middle income?
Offer a very short reply. 31.52. What is the ratio of the Aid flow (current US$) in 1962 in Low & middle income to that in Lower middle income?
Provide a short and direct response. 18.91. What is the ratio of the Aid flow (current US$) of 1963 in Low & middle income to that in Lower middle income?
Your answer should be compact. 10.38. What is the difference between the highest and the second highest Aid flow (current US$) in 1960?
Your response must be concise. 7.37e+08. What is the difference between the highest and the second highest Aid flow (current US$) of 1961?
Your answer should be compact. 8.27e+08. What is the difference between the highest and the second highest Aid flow (current US$) in 1962?
Give a very brief answer. 7.87e+08. What is the difference between the highest and the second highest Aid flow (current US$) in 1963?
Provide a short and direct response. 7.17e+08. What is the difference between the highest and the lowest Aid flow (current US$) in 1960?
Provide a succinct answer. 7.76e+08. What is the difference between the highest and the lowest Aid flow (current US$) in 1961?
Provide a succinct answer. 8.43e+08. What is the difference between the highest and the lowest Aid flow (current US$) in 1962?
Keep it short and to the point. 8.31e+08. What is the difference between the highest and the lowest Aid flow (current US$) in 1963?
Keep it short and to the point. 7.94e+08. 